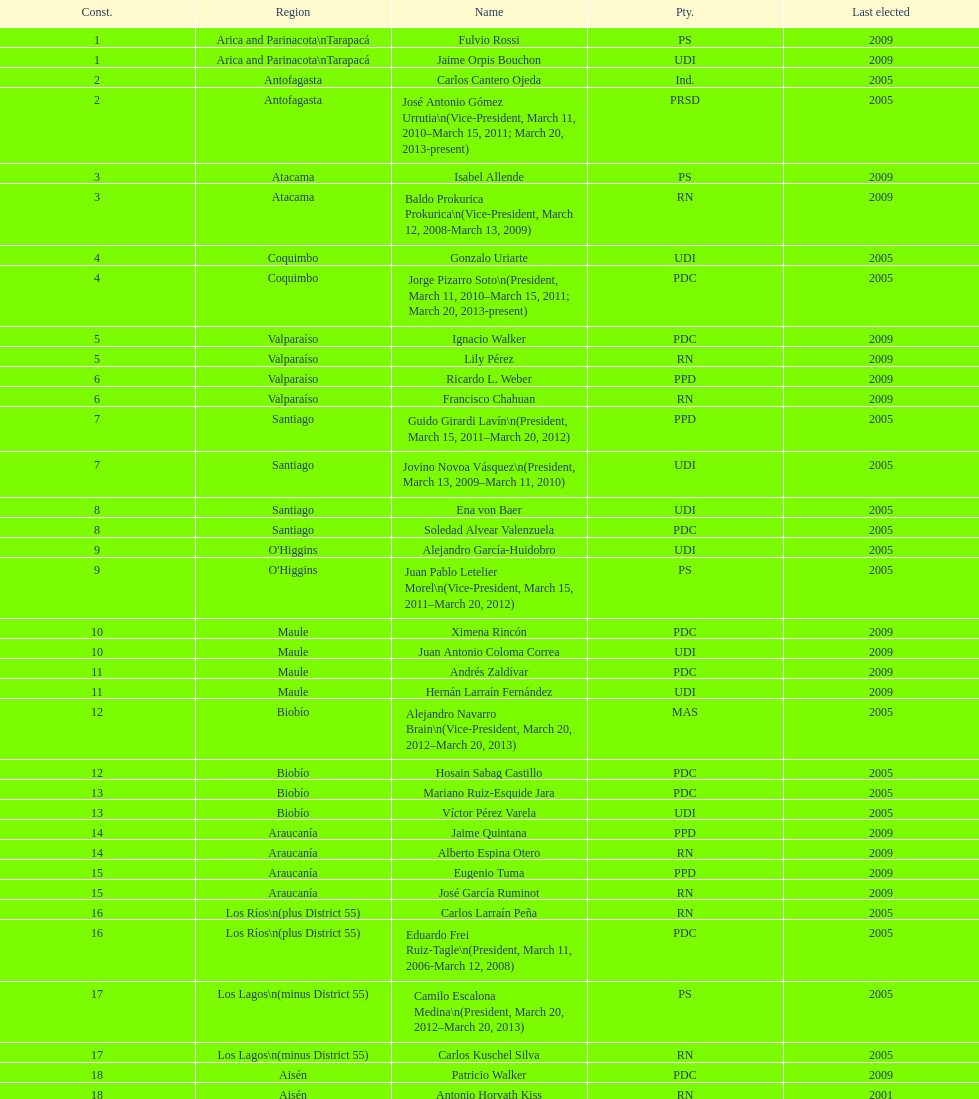What is the first name on the table? Fulvio Rossi. Would you be able to parse every entry in this table? {'header': ['Const.', 'Region', 'Name', 'Pty.', 'Last elected'], 'rows': [['1', 'Arica and Parinacota\\nTarapacá', 'Fulvio Rossi', 'PS', '2009'], ['1', 'Arica and Parinacota\\nTarapacá', 'Jaime Orpis Bouchon', 'UDI', '2009'], ['2', 'Antofagasta', 'Carlos Cantero Ojeda', 'Ind.', '2005'], ['2', 'Antofagasta', 'José Antonio Gómez Urrutia\\n(Vice-President, March 11, 2010–March 15, 2011; March 20, 2013-present)', 'PRSD', '2005'], ['3', 'Atacama', 'Isabel Allende', 'PS', '2009'], ['3', 'Atacama', 'Baldo Prokurica Prokurica\\n(Vice-President, March 12, 2008-March 13, 2009)', 'RN', '2009'], ['4', 'Coquimbo', 'Gonzalo Uriarte', 'UDI', '2005'], ['4', 'Coquimbo', 'Jorge Pizarro Soto\\n(President, March 11, 2010–March 15, 2011; March 20, 2013-present)', 'PDC', '2005'], ['5', 'Valparaíso', 'Ignacio Walker', 'PDC', '2009'], ['5', 'Valparaíso', 'Lily Pérez', 'RN', '2009'], ['6', 'Valparaíso', 'Ricardo L. Weber', 'PPD', '2009'], ['6', 'Valparaíso', 'Francisco Chahuan', 'RN', '2009'], ['7', 'Santiago', 'Guido Girardi Lavín\\n(President, March 15, 2011–March 20, 2012)', 'PPD', '2005'], ['7', 'Santiago', 'Jovino Novoa Vásquez\\n(President, March 13, 2009–March 11, 2010)', 'UDI', '2005'], ['8', 'Santiago', 'Ena von Baer', 'UDI', '2005'], ['8', 'Santiago', 'Soledad Alvear Valenzuela', 'PDC', '2005'], ['9', "O'Higgins", 'Alejandro García-Huidobro', 'UDI', '2005'], ['9', "O'Higgins", 'Juan Pablo Letelier Morel\\n(Vice-President, March 15, 2011–March 20, 2012)', 'PS', '2005'], ['10', 'Maule', 'Ximena Rincón', 'PDC', '2009'], ['10', 'Maule', 'Juan Antonio Coloma Correa', 'UDI', '2009'], ['11', 'Maule', 'Andrés Zaldívar', 'PDC', '2009'], ['11', 'Maule', 'Hernán Larraín Fernández', 'UDI', '2009'], ['12', 'Biobío', 'Alejandro Navarro Brain\\n(Vice-President, March 20, 2012–March 20, 2013)', 'MAS', '2005'], ['12', 'Biobío', 'Hosain Sabag Castillo', 'PDC', '2005'], ['13', 'Biobío', 'Mariano Ruiz-Esquide Jara', 'PDC', '2005'], ['13', 'Biobío', 'Víctor Pérez Varela', 'UDI', '2005'], ['14', 'Araucanía', 'Jaime Quintana', 'PPD', '2009'], ['14', 'Araucanía', 'Alberto Espina Otero', 'RN', '2009'], ['15', 'Araucanía', 'Eugenio Tuma', 'PPD', '2009'], ['15', 'Araucanía', 'José García Ruminot', 'RN', '2009'], ['16', 'Los Ríos\\n(plus District 55)', 'Carlos Larraín Peña', 'RN', '2005'], ['16', 'Los Ríos\\n(plus District 55)', 'Eduardo Frei Ruiz-Tagle\\n(President, March 11, 2006-March 12, 2008)', 'PDC', '2005'], ['17', 'Los Lagos\\n(minus District 55)', 'Camilo Escalona Medina\\n(President, March 20, 2012–March 20, 2013)', 'PS', '2005'], ['17', 'Los Lagos\\n(minus District 55)', 'Carlos Kuschel Silva', 'RN', '2005'], ['18', 'Aisén', 'Patricio Walker', 'PDC', '2009'], ['18', 'Aisén', 'Antonio Horvath Kiss', 'RN', '2001'], ['19', 'Magallanes', 'Carlos Bianchi Chelech\\n(Vice-President, March 13, 2009–March 11, 2010)', 'Ind.', '2005'], ['19', 'Magallanes', 'Pedro Muñoz Aburto', 'PS', '2005']]} 